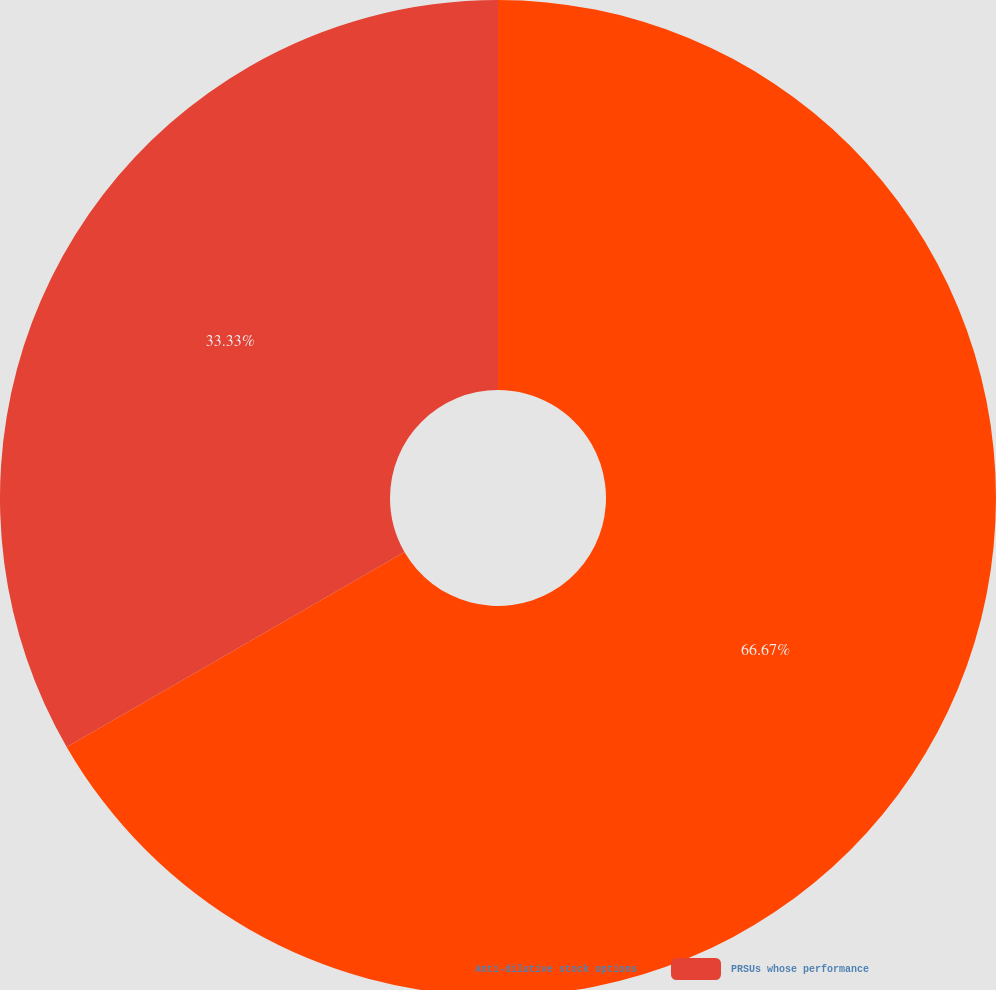Convert chart to OTSL. <chart><loc_0><loc_0><loc_500><loc_500><pie_chart><fcel>Anti-dilutive stock options<fcel>PRSUs whose performance<nl><fcel>66.67%<fcel>33.33%<nl></chart> 